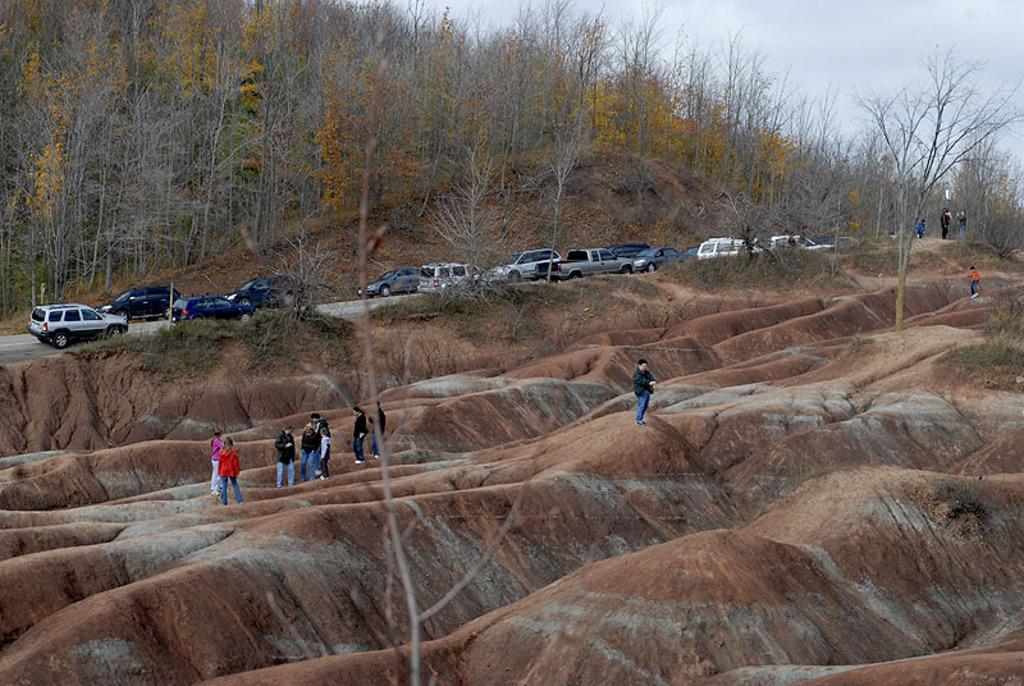Please provide a concise description of this image. In the picture I can see people standing on the ground. In the background I can see vehicles on the road, trees, the sky and some other objects. 